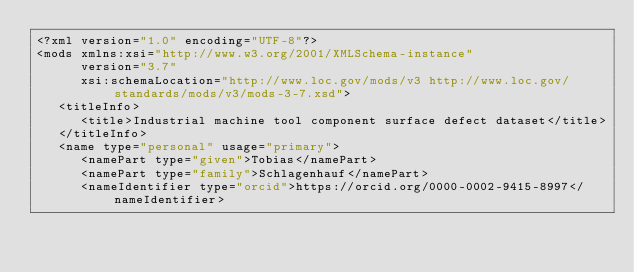<code> <loc_0><loc_0><loc_500><loc_500><_XML_><?xml version="1.0" encoding="UTF-8"?>
<mods xmlns:xsi="http://www.w3.org/2001/XMLSchema-instance"
      version="3.7"
      xsi:schemaLocation="http://www.loc.gov/mods/v3 http://www.loc.gov/standards/mods/v3/mods-3-7.xsd">
   <titleInfo>
      <title>Industrial machine tool component surface defect dataset</title>
   </titleInfo>
   <name type="personal" usage="primary">
      <namePart type="given">Tobias</namePart>
      <namePart type="family">Schlagenhauf</namePart>
      <nameIdentifier type="orcid">https://orcid.org/0000-0002-9415-8997</nameIdentifier></code> 